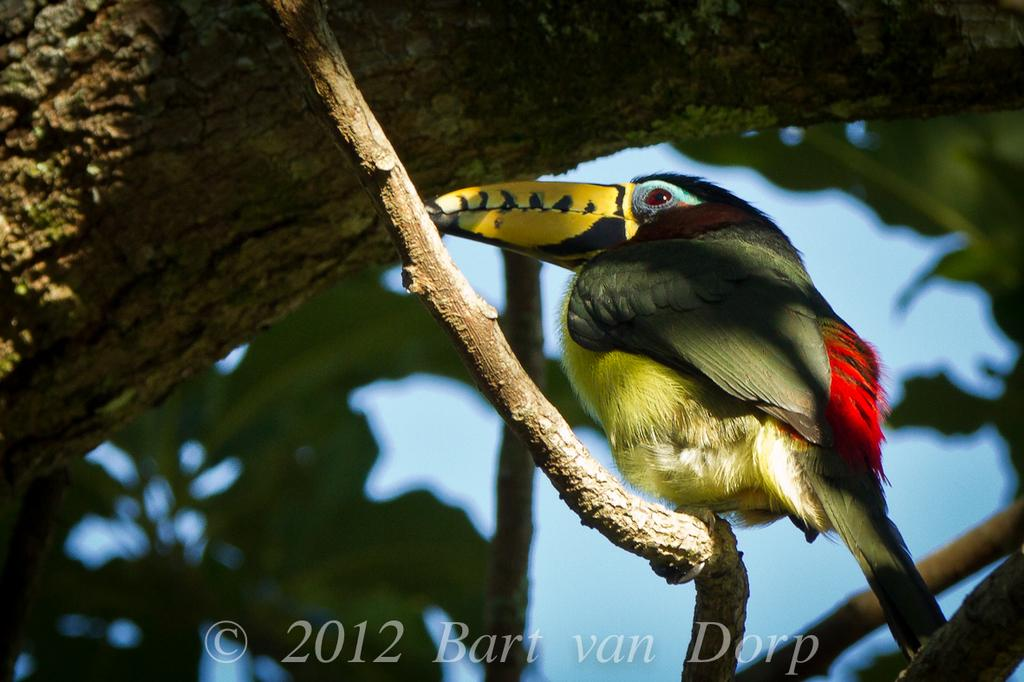What type of animal can be seen in the image? There is a bird in the image. Where is the bird located? The bird is on the branch of a tree. What can be seen in the background of the image? There is a sky visible in the background of the image. What type of bait is the bird using to catch fish in the image? There is no bait or fish present in the image; it features a bird on a tree branch with a visible sky in the background. 